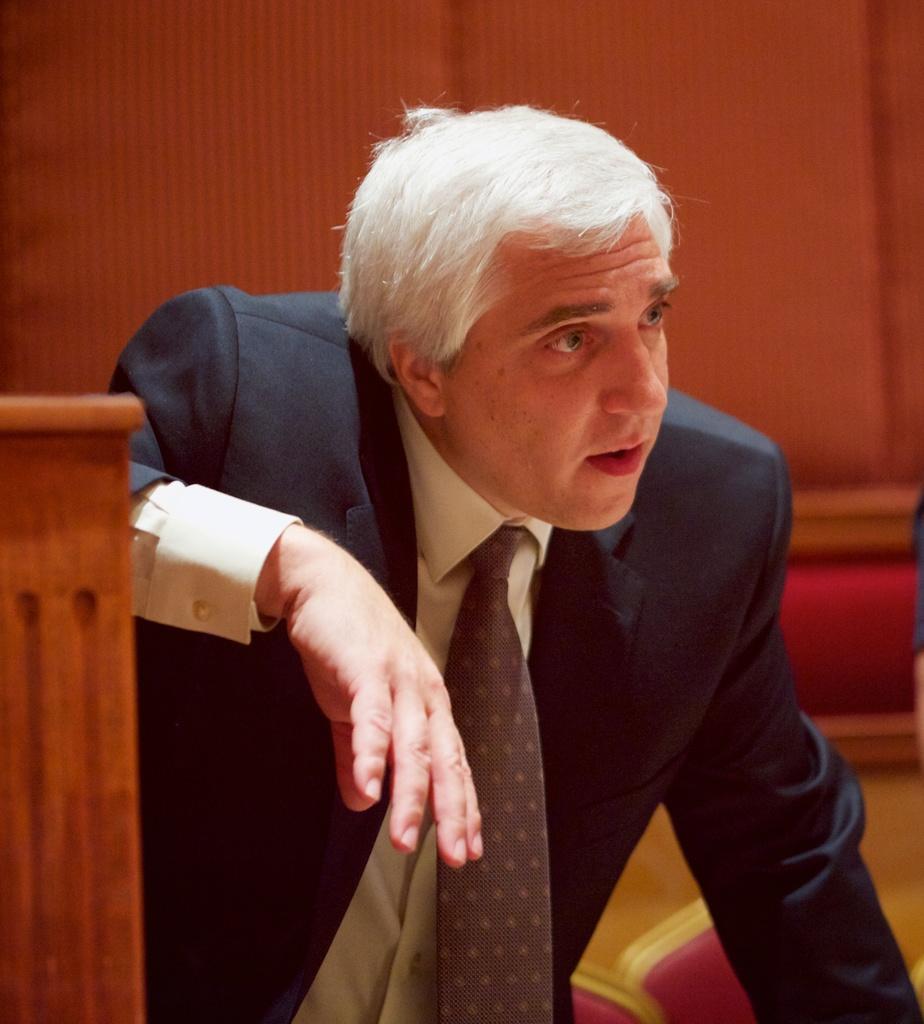Please provide a concise description of this image. In this image, we can see a person in a suit. On the left side of the image, we can see a wooden object. At the bottom, there are few objects. Background we can see a blur view. 